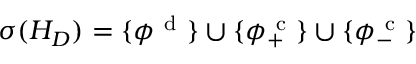Convert formula to latex. <formula><loc_0><loc_0><loc_500><loc_500>\sigma ( H _ { D } ) = \{ \phi ^ { d } \} \cup \{ \phi _ { + } ^ { c } \} \cup \{ \phi _ { - } ^ { c } \}</formula> 